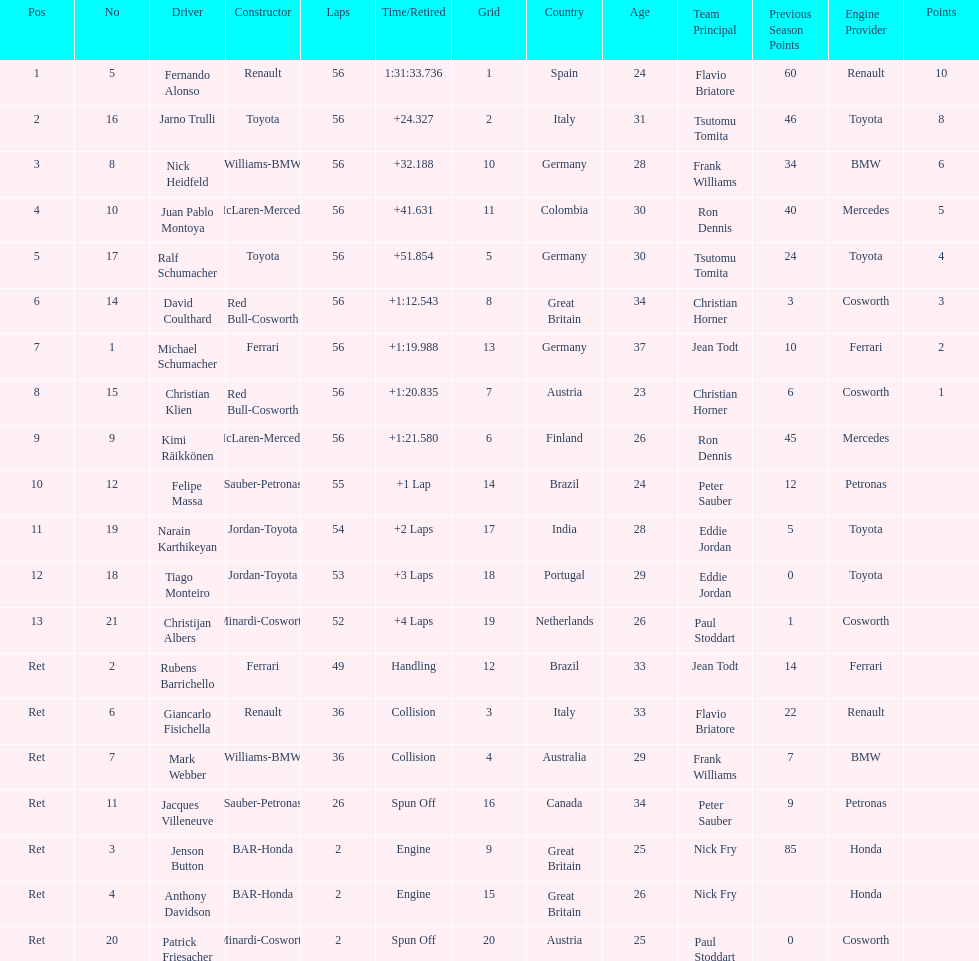How long did it take fernando alonso to finish the race? 1:31:33.736. 